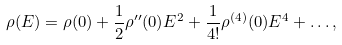<formula> <loc_0><loc_0><loc_500><loc_500>\rho ( E ) = \rho ( 0 ) + \frac { 1 } { 2 } \rho ^ { \prime \prime } ( 0 ) E ^ { 2 } + \frac { 1 } { 4 ! } \rho ^ { ( 4 ) } ( 0 ) E ^ { 4 } + \dots ,</formula> 